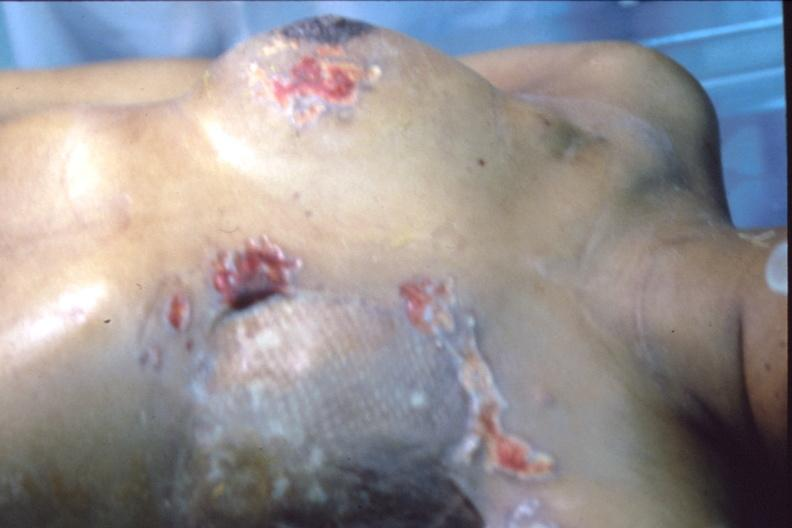s breast present?
Answer the question using a single word or phrase. Yes 